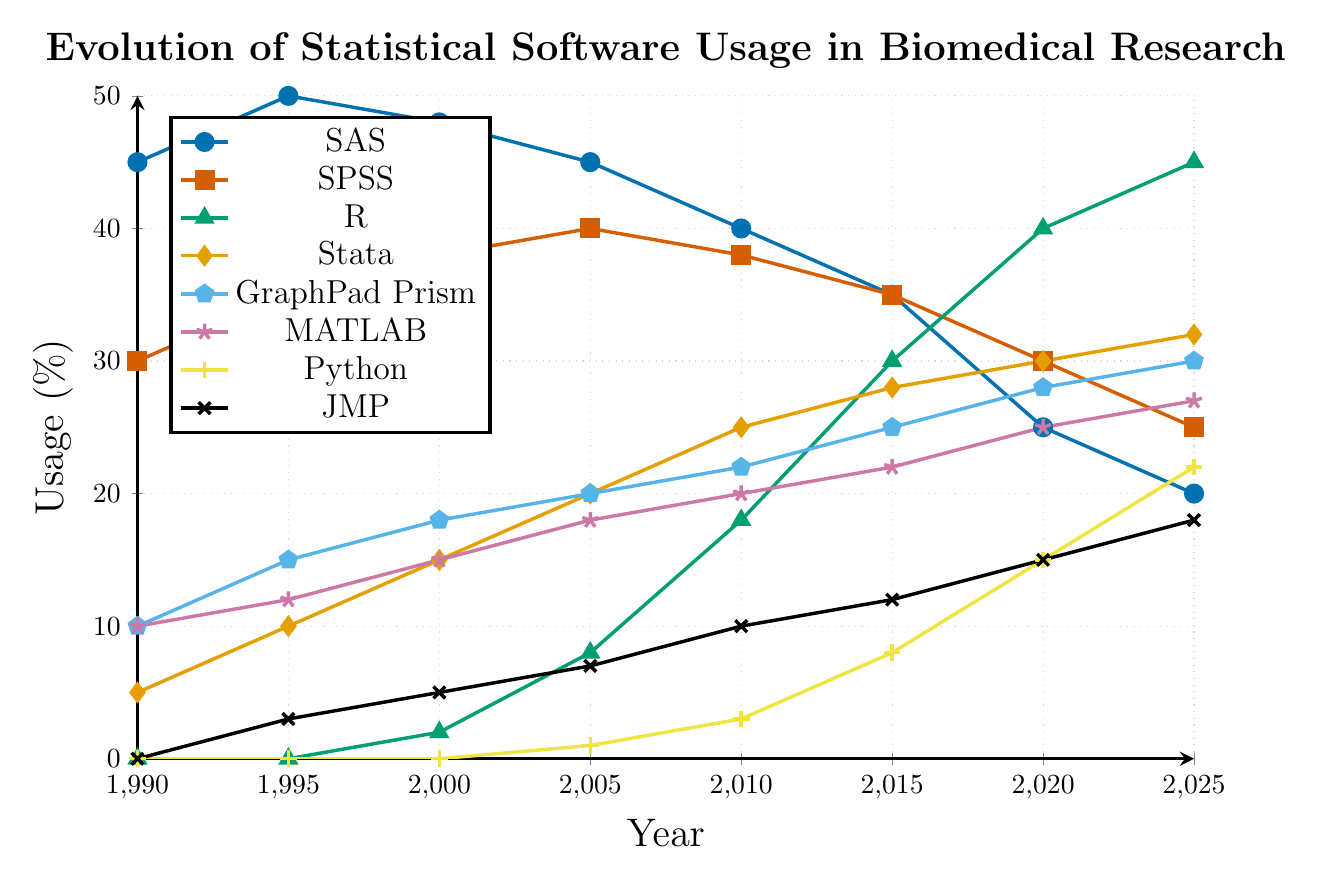What is the trend of SAS usage from 1990 to 2025? The percentage of SAS usage starts at 45% in 1990, rises to 50% in 1995, and then gradually declines to 20% by 2025.
Answer: Gradual decline Which software shows the most significant increase in usage from 1990 to 2025? By comparing the initial and final values, R increases from 0% in 1990 to 45% in 2025, indicating the most significant growth.
Answer: R Between which two years did Python usage increase the most? From 2015 to 2020, Python usage increased from 8% to 15%, which is an increase of 7%. This is the largest increase observed in Python usage between any two consecutive years on the chart.
Answer: 2015-2020 What is the combined usage percentage of GraphPad Prism and MATLAB in 2025? GraphPad Prism has a usage of 30% and MATLAB has 27% in 2025. Adding them gives 30% + 27%.
Answer: 57% How does the usage of SPSS in 2025 compare to its usage in 1990? SPSS usage begins at 30% in 1990 and decreases to 25% in 2025. This shows a decline of 5 percentage points over the period.
Answer: Declined by 5 percentage points Which software had zero usage in 2000 but showed notable usage in 2025? By examining the data, Python had 0% usage in 2000 and increased significantly to 22% by 2025.
Answer: Python What is the average usage of Stata over the entire period from 1990 to 2025? The usage percentages for Stata are: 5, 10, 15, 20, 25, 28, 30, and 32. Summing these values gives 165, and there are 8 data points. The average is 165/8 = 20.625.
Answer: 20.625% Which software has the steadiest increase in usage from 1990 to 2025? Stata shows a consistent increase in usage starting from 5% in 1990 to 32% in 2025, with no decreases or major fluctuations.
Answer: Stata By what percentage did JMP usage increase from 1995 to 2005? JMP usage in 1995 is 3% and in 2005 it is 7%. The increase is calculated as (7 - 3) / 3 * 100% = 133.3%.
Answer: 133.3% In which year did MATLAB usage surpass SPSS usage? MATLAB usage surpasses SPSS in 2025 with MATLAB at 27% and SPSS at 25%.
Answer: 2025 